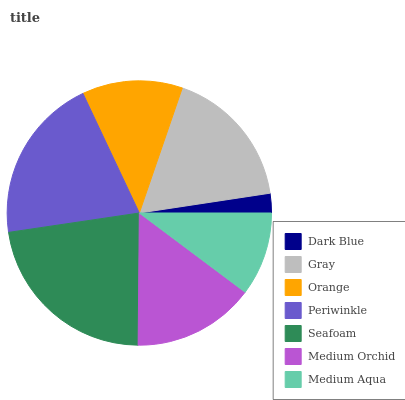Is Dark Blue the minimum?
Answer yes or no. Yes. Is Seafoam the maximum?
Answer yes or no. Yes. Is Gray the minimum?
Answer yes or no. No. Is Gray the maximum?
Answer yes or no. No. Is Gray greater than Dark Blue?
Answer yes or no. Yes. Is Dark Blue less than Gray?
Answer yes or no. Yes. Is Dark Blue greater than Gray?
Answer yes or no. No. Is Gray less than Dark Blue?
Answer yes or no. No. Is Medium Orchid the high median?
Answer yes or no. Yes. Is Medium Orchid the low median?
Answer yes or no. Yes. Is Dark Blue the high median?
Answer yes or no. No. Is Orange the low median?
Answer yes or no. No. 